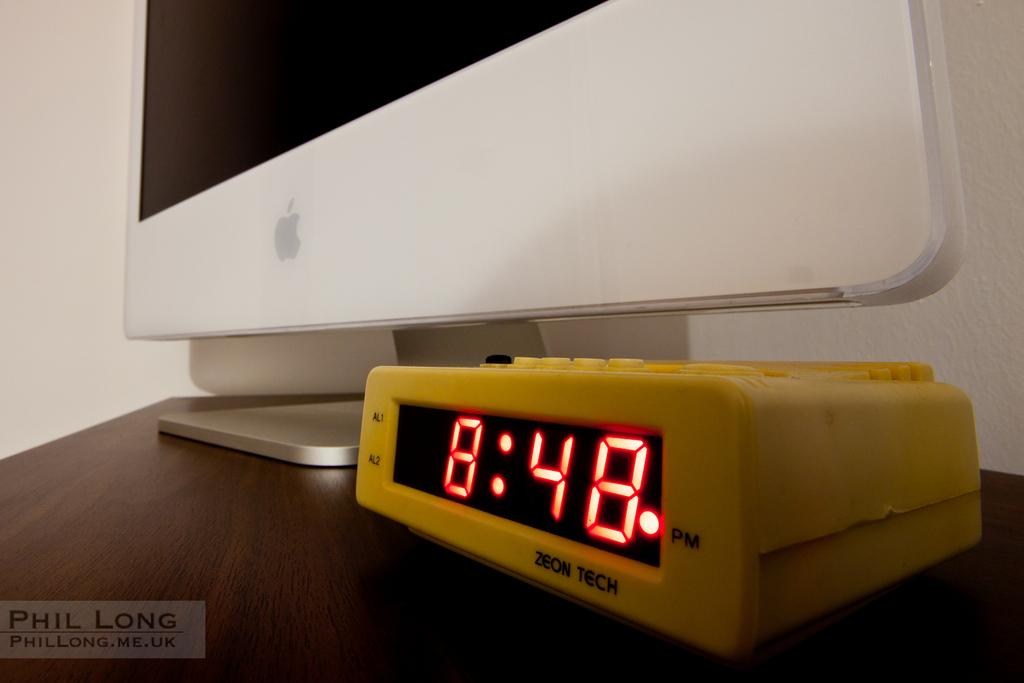<image>
Create a compact narrative representing the image presented. The yellow alarm clock beneath an Apple computer reads 8:48PM 